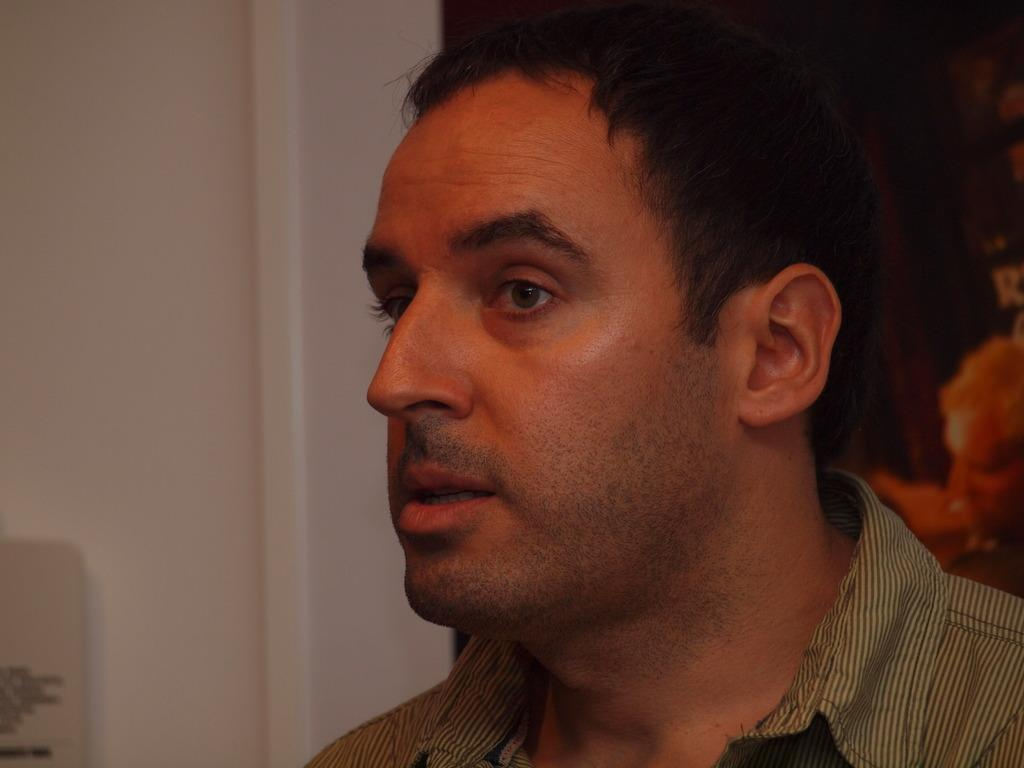Who or what is the main subject in the image? There is a person in the image. What is the person wearing? The person is wearing a shirt. What can be seen in the background of the image? There is a white wall in the background of the image. On which side of the image is the white wall located? The white wall is on the left side. Can you see any ducks in the image? No, there are no ducks present in the image. Is there a church visible in the image? No, there is no church visible in the image. 